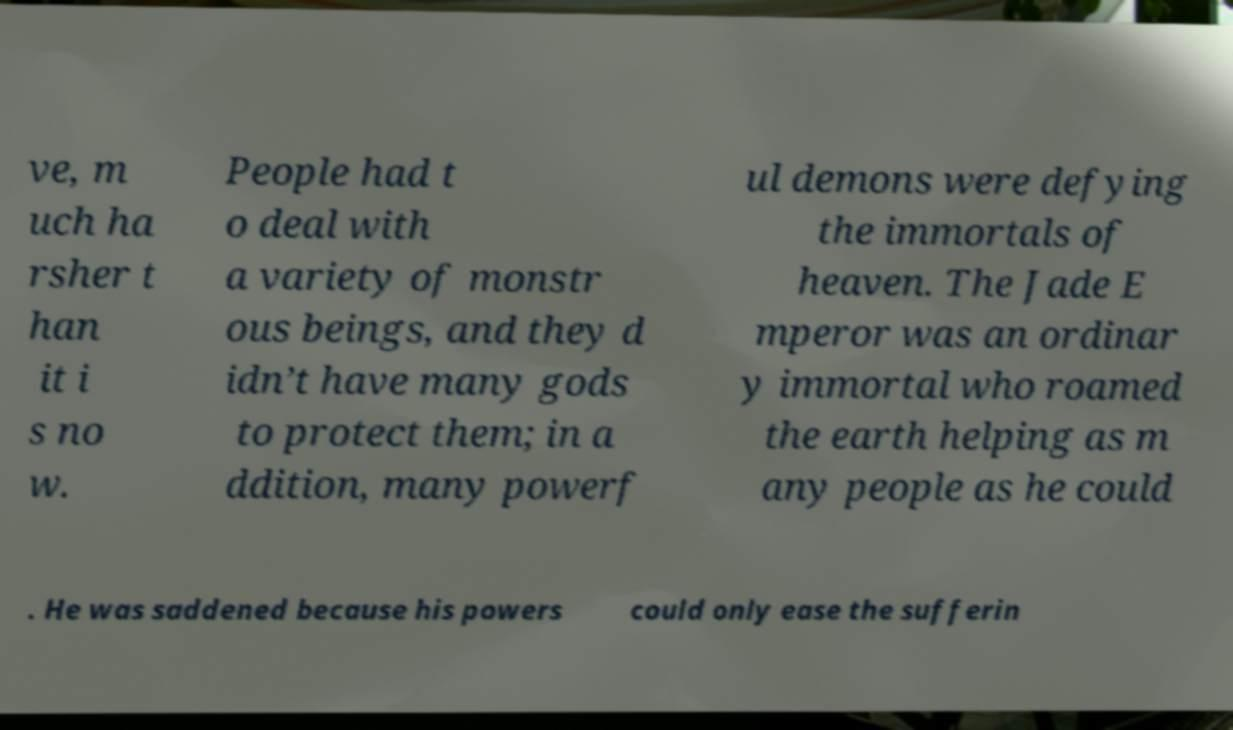I need the written content from this picture converted into text. Can you do that? ve, m uch ha rsher t han it i s no w. People had t o deal with a variety of monstr ous beings, and they d idn’t have many gods to protect them; in a ddition, many powerf ul demons were defying the immortals of heaven. The Jade E mperor was an ordinar y immortal who roamed the earth helping as m any people as he could . He was saddened because his powers could only ease the sufferin 